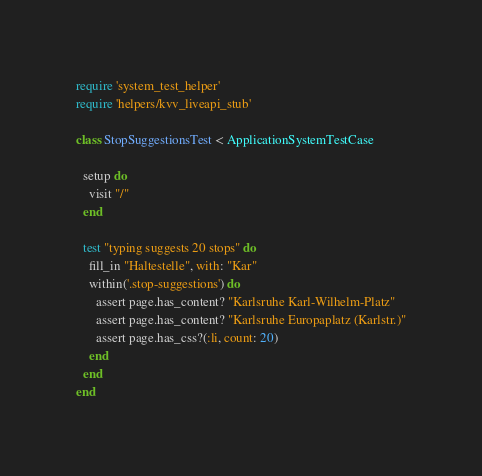<code> <loc_0><loc_0><loc_500><loc_500><_Ruby_>require 'system_test_helper'
require 'helpers/kvv_liveapi_stub'

class StopSuggestionsTest < ApplicationSystemTestCase

  setup do
    visit "/"
  end

  test "typing suggests 20 stops" do
    fill_in "Haltestelle", with: "Kar"
    within('.stop-suggestions') do
      assert page.has_content? "Karlsruhe Karl-Wilhelm-Platz"
      assert page.has_content? "Karlsruhe Europaplatz (Karlstr.)"
      assert page.has_css?(:li, count: 20)
    end
  end
end
</code> 